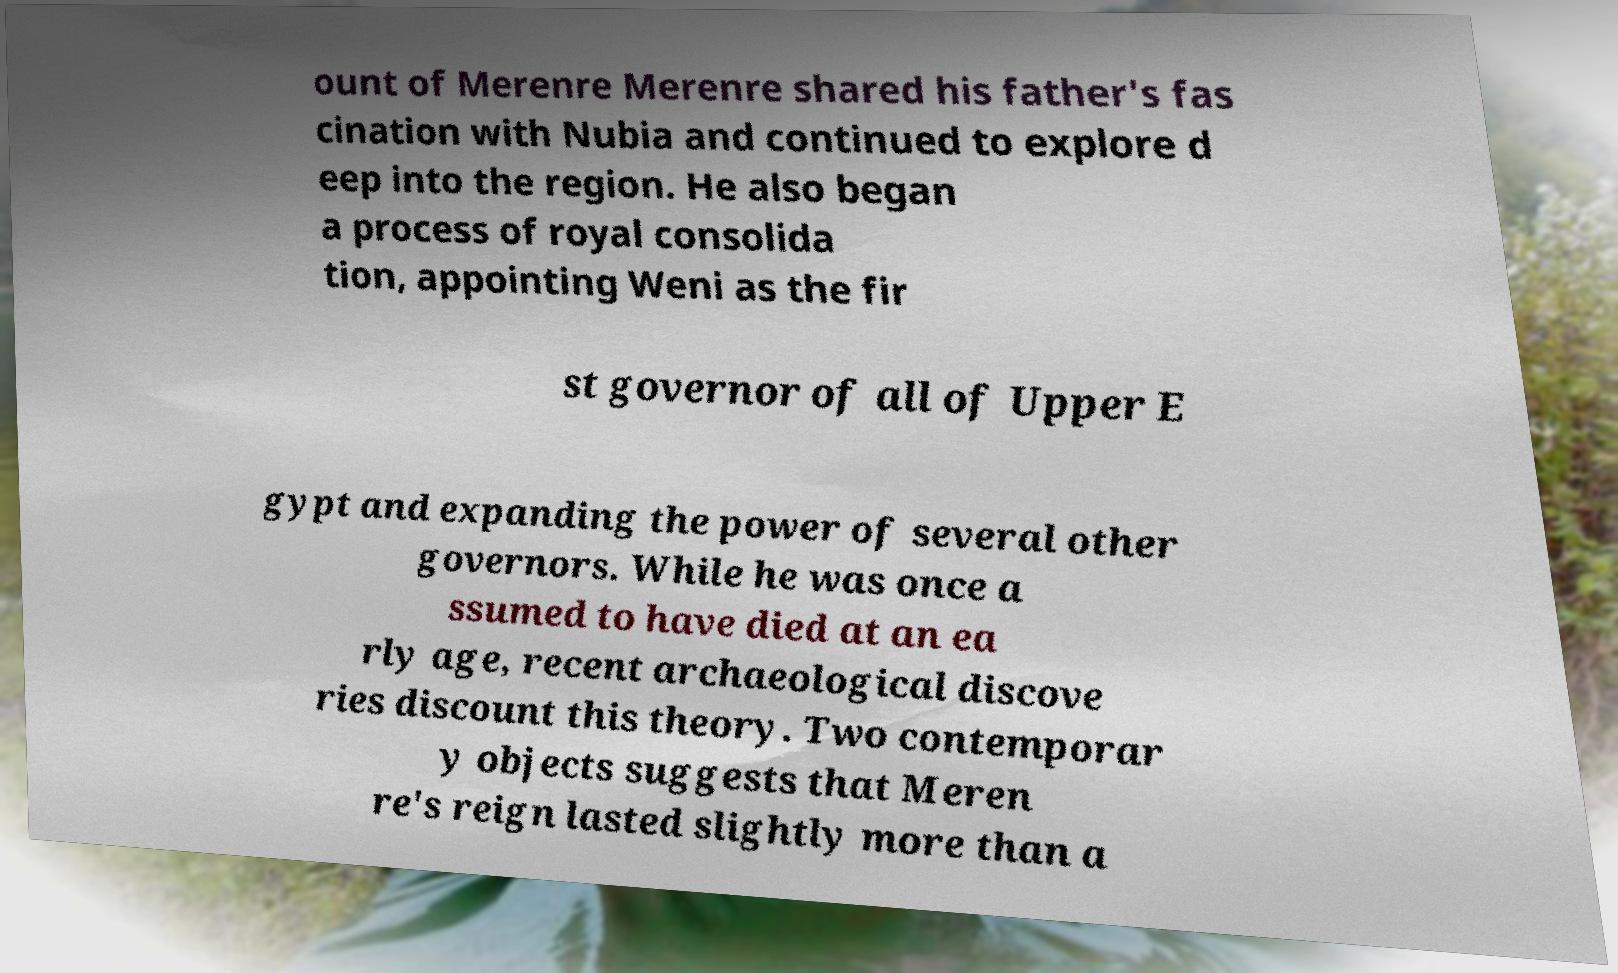I need the written content from this picture converted into text. Can you do that? ount of Merenre Merenre shared his father's fas cination with Nubia and continued to explore d eep into the region. He also began a process of royal consolida tion, appointing Weni as the fir st governor of all of Upper E gypt and expanding the power of several other governors. While he was once a ssumed to have died at an ea rly age, recent archaeological discove ries discount this theory. Two contemporar y objects suggests that Meren re's reign lasted slightly more than a 